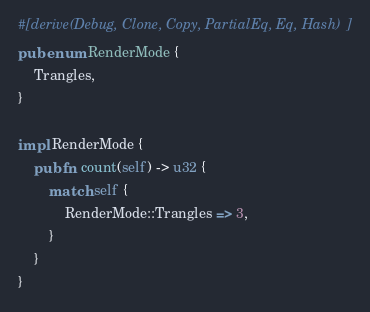Convert code to text. <code><loc_0><loc_0><loc_500><loc_500><_Rust_>#[derive(Debug, Clone, Copy, PartialEq, Eq, Hash)]
pub enum RenderMode {
    Trangles,
}

impl RenderMode {
    pub fn count(self) -> u32 {
        match self {
            RenderMode::Trangles => 3,
        }
    }
}
</code> 